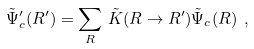<formula> <loc_0><loc_0><loc_500><loc_500>\tilde { \Psi } _ { c } ^ { \prime } ( { R } ^ { \prime } ) = \sum _ { R } \, \tilde { K } ( { R } \rightarrow { R } ^ { \prime } ) \tilde { \Psi } _ { c } ( { R } ) \ ,</formula> 